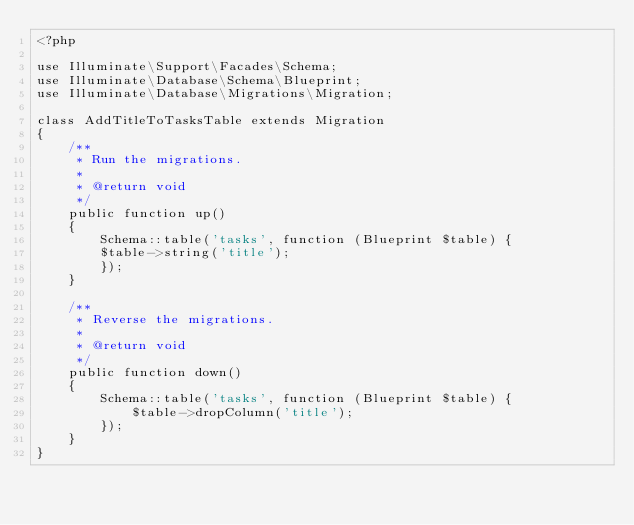<code> <loc_0><loc_0><loc_500><loc_500><_PHP_><?php

use Illuminate\Support\Facades\Schema;
use Illuminate\Database\Schema\Blueprint;
use Illuminate\Database\Migrations\Migration;

class AddTitleToTasksTable extends Migration
{
    /**
     * Run the migrations.
     *
     * @return void
     */
    public function up()
    {
        Schema::table('tasks', function (Blueprint $table) {
        $table->string('title');
        });
    }

    /**
     * Reverse the migrations.
     *
     * @return void
     */
    public function down()
    {
        Schema::table('tasks', function (Blueprint $table) {
            $table->dropColumn('title');
        });
    }
}
</code> 